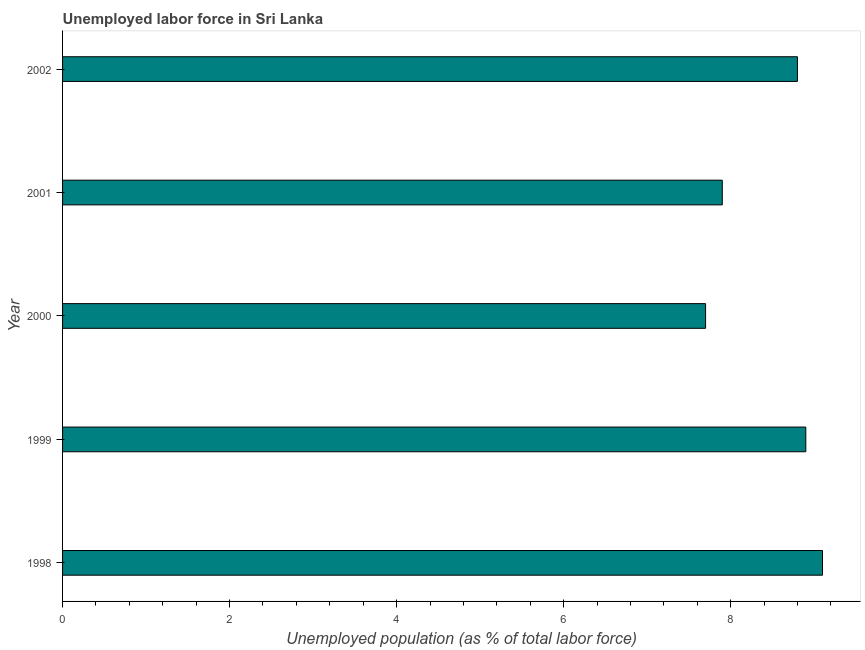Does the graph contain any zero values?
Your answer should be compact. No. Does the graph contain grids?
Ensure brevity in your answer.  No. What is the title of the graph?
Your answer should be compact. Unemployed labor force in Sri Lanka. What is the label or title of the X-axis?
Give a very brief answer. Unemployed population (as % of total labor force). What is the total unemployed population in 2002?
Your response must be concise. 8.8. Across all years, what is the maximum total unemployed population?
Your answer should be very brief. 9.1. Across all years, what is the minimum total unemployed population?
Provide a succinct answer. 7.7. In which year was the total unemployed population maximum?
Give a very brief answer. 1998. What is the sum of the total unemployed population?
Your answer should be compact. 42.4. What is the average total unemployed population per year?
Make the answer very short. 8.48. What is the median total unemployed population?
Your answer should be very brief. 8.8. In how many years, is the total unemployed population greater than 4.8 %?
Provide a succinct answer. 5. What is the ratio of the total unemployed population in 2001 to that in 2002?
Your answer should be very brief. 0.9. What is the difference between the highest and the second highest total unemployed population?
Provide a short and direct response. 0.2. Is the sum of the total unemployed population in 1998 and 2000 greater than the maximum total unemployed population across all years?
Your answer should be very brief. Yes. In how many years, is the total unemployed population greater than the average total unemployed population taken over all years?
Ensure brevity in your answer.  3. How many bars are there?
Provide a succinct answer. 5. Are all the bars in the graph horizontal?
Provide a short and direct response. Yes. How many years are there in the graph?
Your response must be concise. 5. Are the values on the major ticks of X-axis written in scientific E-notation?
Offer a very short reply. No. What is the Unemployed population (as % of total labor force) of 1998?
Keep it short and to the point. 9.1. What is the Unemployed population (as % of total labor force) in 1999?
Ensure brevity in your answer.  8.9. What is the Unemployed population (as % of total labor force) in 2000?
Your response must be concise. 7.7. What is the Unemployed population (as % of total labor force) in 2001?
Your response must be concise. 7.9. What is the Unemployed population (as % of total labor force) of 2002?
Offer a terse response. 8.8. What is the difference between the Unemployed population (as % of total labor force) in 1999 and 2002?
Your response must be concise. 0.1. What is the difference between the Unemployed population (as % of total labor force) in 2000 and 2001?
Provide a succinct answer. -0.2. What is the difference between the Unemployed population (as % of total labor force) in 2000 and 2002?
Give a very brief answer. -1.1. What is the difference between the Unemployed population (as % of total labor force) in 2001 and 2002?
Ensure brevity in your answer.  -0.9. What is the ratio of the Unemployed population (as % of total labor force) in 1998 to that in 1999?
Provide a succinct answer. 1.02. What is the ratio of the Unemployed population (as % of total labor force) in 1998 to that in 2000?
Your answer should be very brief. 1.18. What is the ratio of the Unemployed population (as % of total labor force) in 1998 to that in 2001?
Offer a very short reply. 1.15. What is the ratio of the Unemployed population (as % of total labor force) in 1998 to that in 2002?
Offer a terse response. 1.03. What is the ratio of the Unemployed population (as % of total labor force) in 1999 to that in 2000?
Provide a succinct answer. 1.16. What is the ratio of the Unemployed population (as % of total labor force) in 1999 to that in 2001?
Provide a short and direct response. 1.13. What is the ratio of the Unemployed population (as % of total labor force) in 2001 to that in 2002?
Your response must be concise. 0.9. 